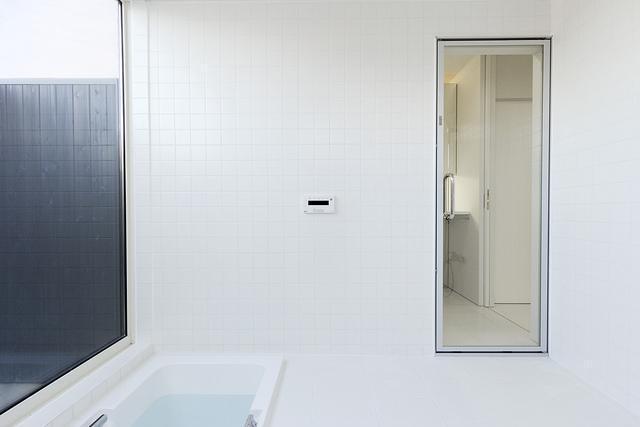How many train tracks are there?
Give a very brief answer. 0. 